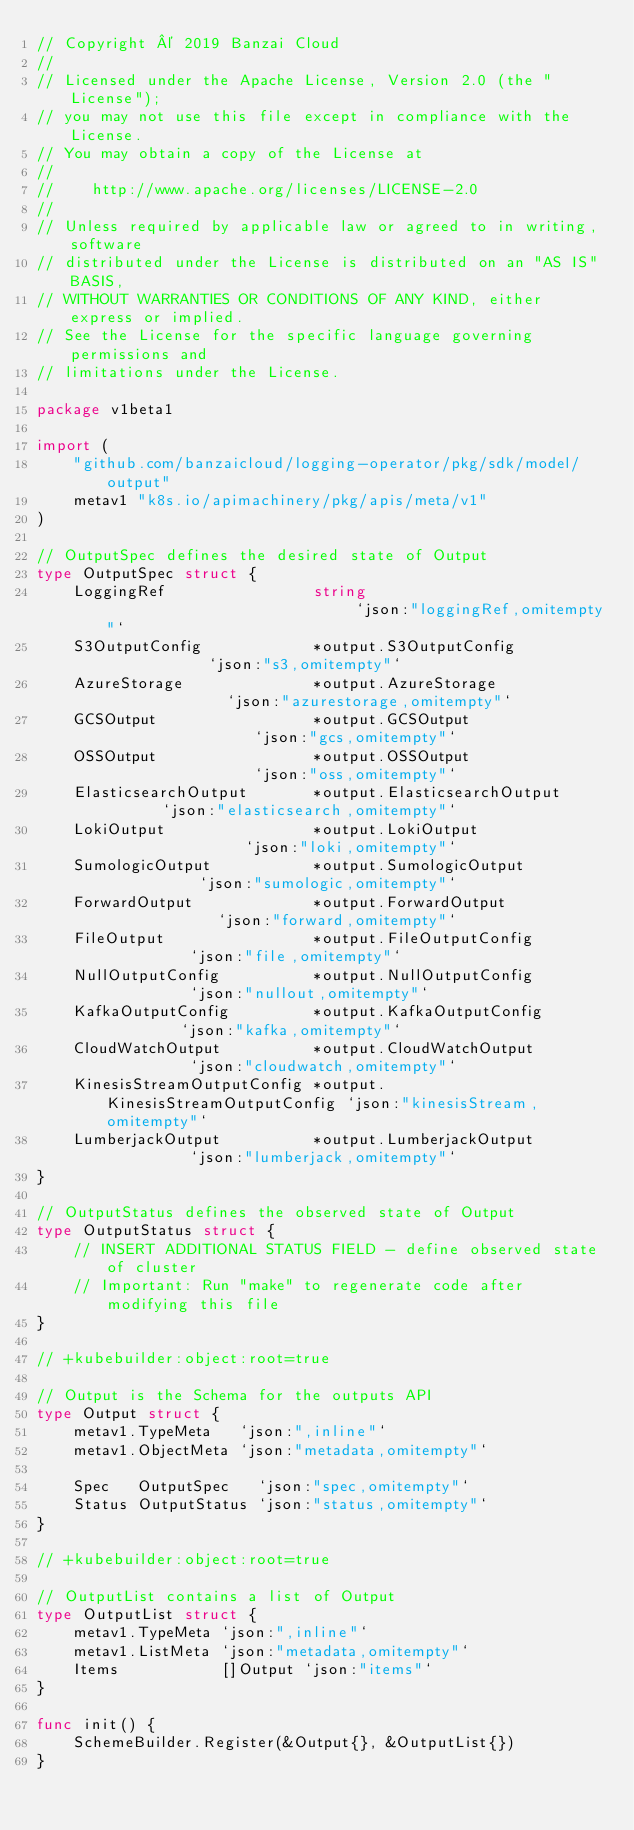<code> <loc_0><loc_0><loc_500><loc_500><_Go_>// Copyright © 2019 Banzai Cloud
//
// Licensed under the Apache License, Version 2.0 (the "License");
// you may not use this file except in compliance with the License.
// You may obtain a copy of the License at
//
//    http://www.apache.org/licenses/LICENSE-2.0
//
// Unless required by applicable law or agreed to in writing, software
// distributed under the License is distributed on an "AS IS" BASIS,
// WITHOUT WARRANTIES OR CONDITIONS OF ANY KIND, either express or implied.
// See the License for the specific language governing permissions and
// limitations under the License.

package v1beta1

import (
	"github.com/banzaicloud/logging-operator/pkg/sdk/model/output"
	metav1 "k8s.io/apimachinery/pkg/apis/meta/v1"
)

// OutputSpec defines the desired state of Output
type OutputSpec struct {
	LoggingRef                string                            `json:"loggingRef,omitempty"`
	S3OutputConfig            *output.S3OutputConfig            `json:"s3,omitempty"`
	AzureStorage              *output.AzureStorage              `json:"azurestorage,omitempty"`
	GCSOutput                 *output.GCSOutput                 `json:"gcs,omitempty"`
	OSSOutput                 *output.OSSOutput                 `json:"oss,omitempty"`
	ElasticsearchOutput       *output.ElasticsearchOutput       `json:"elasticsearch,omitempty"`
	LokiOutput                *output.LokiOutput                `json:"loki,omitempty"`
	SumologicOutput           *output.SumologicOutput           `json:"sumologic,omitempty"`
	ForwardOutput             *output.ForwardOutput             `json:"forward,omitempty"`
	FileOutput                *output.FileOutputConfig          `json:"file,omitempty"`
	NullOutputConfig          *output.NullOutputConfig          `json:"nullout,omitempty"`
	KafkaOutputConfig         *output.KafkaOutputConfig         `json:"kafka,omitempty"`
	CloudWatchOutput          *output.CloudWatchOutput          `json:"cloudwatch,omitempty"`
	KinesisStreamOutputConfig *output.KinesisStreamOutputConfig `json:"kinesisStream,omitempty"`
	LumberjackOutput          *output.LumberjackOutput          `json:"lumberjack,omitempty"`
}

// OutputStatus defines the observed state of Output
type OutputStatus struct {
	// INSERT ADDITIONAL STATUS FIELD - define observed state of cluster
	// Important: Run "make" to regenerate code after modifying this file
}

// +kubebuilder:object:root=true

// Output is the Schema for the outputs API
type Output struct {
	metav1.TypeMeta   `json:",inline"`
	metav1.ObjectMeta `json:"metadata,omitempty"`

	Spec   OutputSpec   `json:"spec,omitempty"`
	Status OutputStatus `json:"status,omitempty"`
}

// +kubebuilder:object:root=true

// OutputList contains a list of Output
type OutputList struct {
	metav1.TypeMeta `json:",inline"`
	metav1.ListMeta `json:"metadata,omitempty"`
	Items           []Output `json:"items"`
}

func init() {
	SchemeBuilder.Register(&Output{}, &OutputList{})
}
</code> 